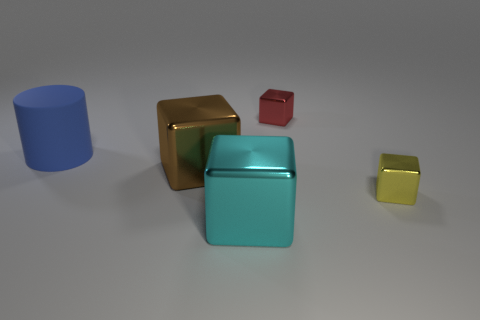Add 5 tiny blue shiny cylinders. How many objects exist? 10 Subtract all cylinders. How many objects are left? 4 Subtract 0 purple cylinders. How many objects are left? 5 Subtract all yellow blocks. Subtract all matte cylinders. How many objects are left? 3 Add 5 large metallic objects. How many large metallic objects are left? 7 Add 1 blue matte blocks. How many blue matte blocks exist? 1 